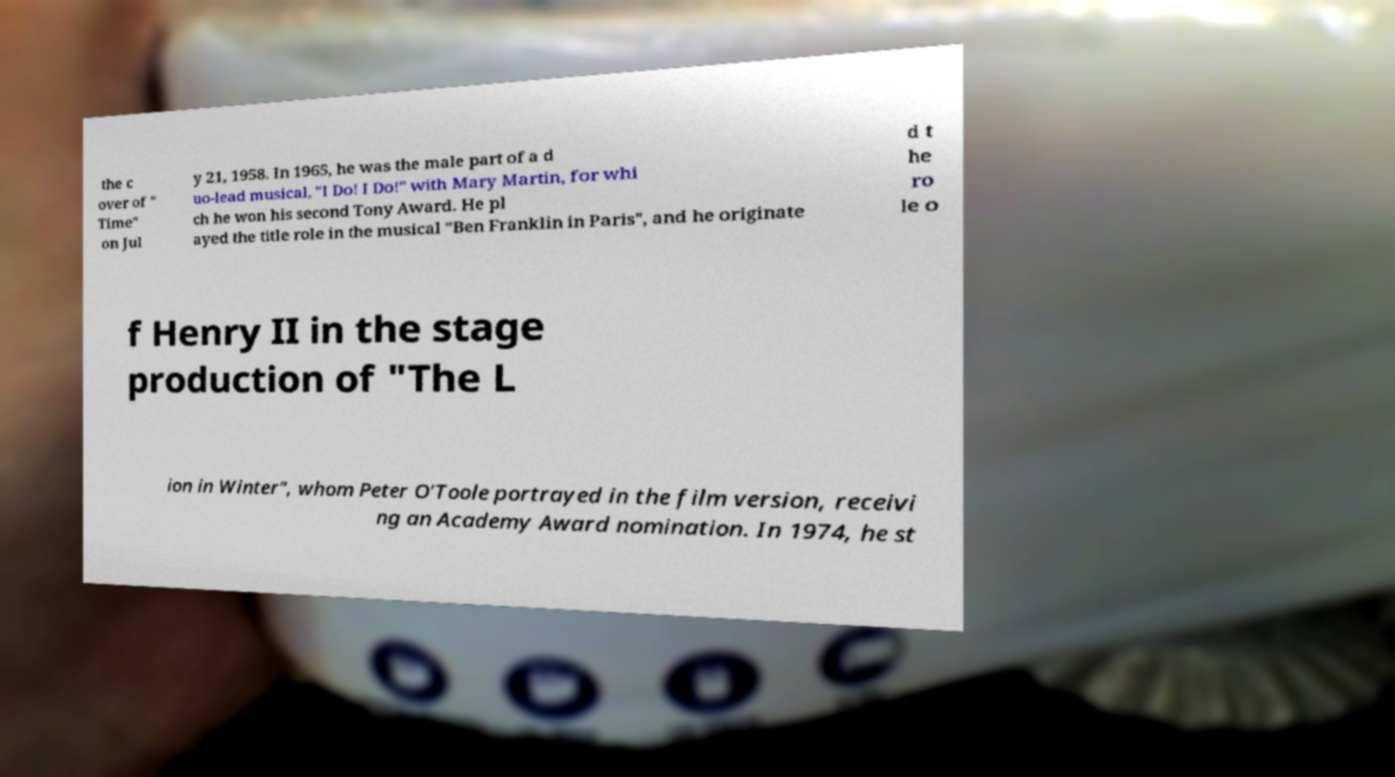Can you accurately transcribe the text from the provided image for me? the c over of " Time" on Jul y 21, 1958. In 1965, he was the male part of a d uo-lead musical, "I Do! I Do!" with Mary Martin, for whi ch he won his second Tony Award. He pl ayed the title role in the musical "Ben Franklin in Paris", and he originate d t he ro le o f Henry II in the stage production of "The L ion in Winter", whom Peter O'Toole portrayed in the film version, receivi ng an Academy Award nomination. In 1974, he st 